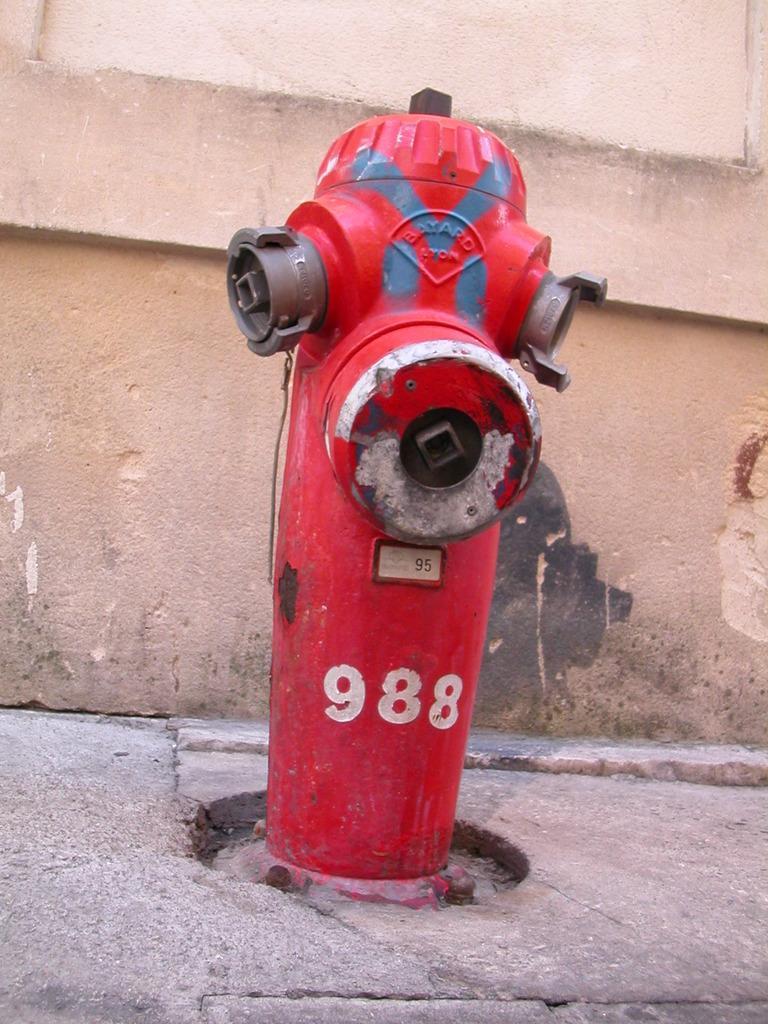Could you give a brief overview of what you see in this image? In this image I can see the red color fire hydrant and there is a number 988 is written on it. In the back I can see the wall. 